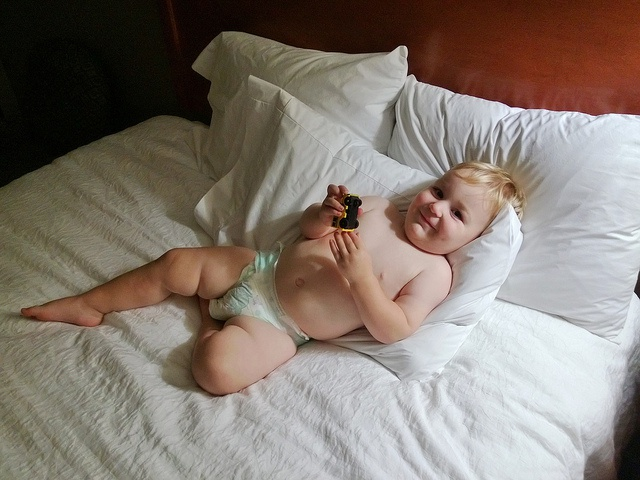Describe the objects in this image and their specific colors. I can see bed in darkgray, lightgray, gray, black, and maroon tones and people in black, gray, tan, maroon, and darkgray tones in this image. 